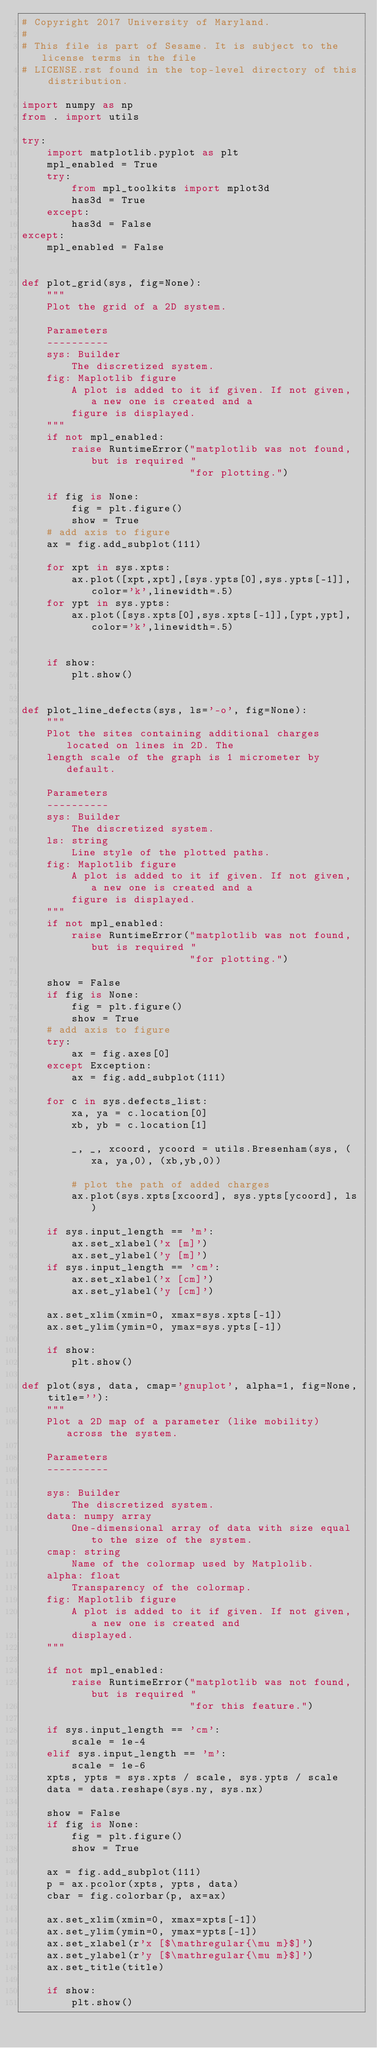<code> <loc_0><loc_0><loc_500><loc_500><_Python_># Copyright 2017 University of Maryland.
#
# This file is part of Sesame. It is subject to the license terms in the file
# LICENSE.rst found in the top-level directory of this distribution.

import numpy as np
from . import utils

try:
    import matplotlib.pyplot as plt
    mpl_enabled = True
    try:
        from mpl_toolkits import mplot3d
        has3d = True
    except:
        has3d = False
except:
    mpl_enabled = False


def plot_grid(sys, fig=None):
    """
    Plot the grid of a 2D system.

    Parameters
    ----------
    sys: Builder
        The discretized system.
    fig: Maplotlib figure
        A plot is added to it if given. If not given, a new one is created and a
        figure is displayed.
    """
    if not mpl_enabled:
        raise RuntimeError("matplotlib was not found, but is required "
                           "for plotting.")

    if fig is None:
        fig = plt.figure()
        show = True
    # add axis to figure
    ax = fig.add_subplot(111)

    for xpt in sys.xpts:
        ax.plot([xpt,xpt],[sys.ypts[0],sys.ypts[-1]],color='k',linewidth=.5)
    for ypt in sys.ypts:
        ax.plot([sys.xpts[0],sys.xpts[-1]],[ypt,ypt],color='k',linewidth=.5)


    if show:
        plt.show()


def plot_line_defects(sys, ls='-o', fig=None):
    """
    Plot the sites containing additional charges located on lines in 2D. The
    length scale of the graph is 1 micrometer by default.

    Parameters
    ----------
    sys: Builder
        The discretized system.
    ls: string
        Line style of the plotted paths.
    fig: Maplotlib figure
        A plot is added to it if given. If not given, a new one is created and a
        figure is displayed.
    """
    if not mpl_enabled:
        raise RuntimeError("matplotlib was not found, but is required "
                           "for plotting.")

    show = False
    if fig is None:
        fig = plt.figure()
        show = True
    # add axis to figure
    try:
        ax = fig.axes[0]
    except Exception:
        ax = fig.add_subplot(111)

    for c in sys.defects_list:
        xa, ya = c.location[0]
        xb, yb = c.location[1]

        _, _, xcoord, ycoord = utils.Bresenham(sys, (xa, ya,0), (xb,yb,0))

        # plot the path of added charges
        ax.plot(sys.xpts[xcoord], sys.ypts[ycoord], ls)

    if sys.input_length == 'm':
        ax.set_xlabel('x [m]')
        ax.set_ylabel('y [m]')
    if sys.input_length == 'cm':
        ax.set_xlabel('x [cm]')
        ax.set_ylabel('y [cm]')
       
    ax.set_xlim(xmin=0, xmax=sys.xpts[-1])
    ax.set_ylim(ymin=0, ymax=sys.ypts[-1])

    if show:
        plt.show()

def plot(sys, data, cmap='gnuplot', alpha=1, fig=None, title=''):
    """
    Plot a 2D map of a parameter (like mobility) across the system.

    Parameters
    ----------

    sys: Builder
        The discretized system.
    data: numpy array
        One-dimensional array of data with size equal to the size of the system.
    cmap: string
        Name of the colormap used by Matplolib.
    alpha: float
        Transparency of the colormap.
    fig: Maplotlib figure
        A plot is added to it if given. If not given, a new one is created and 
        displayed.
    """

    if not mpl_enabled:
        raise RuntimeError("matplotlib was not found, but is required "
                           "for this feature.")

    if sys.input_length == 'cm':
        scale = 1e-4
    elif sys.input_length == 'm':
        scale = 1e-6
    xpts, ypts = sys.xpts / scale, sys.ypts / scale
    data = data.reshape(sys.ny, sys.nx)

    show = False
    if fig is None:
        fig = plt.figure()
        show = True

    ax = fig.add_subplot(111)
    p = ax.pcolor(xpts, ypts, data)
    cbar = fig.colorbar(p, ax=ax)

    ax.set_xlim(xmin=0, xmax=xpts[-1])
    ax.set_ylim(ymin=0, ymax=ypts[-1])
    ax.set_xlabel(r'x [$\mathregular{\mu m}$]')
    ax.set_ylabel(r'y [$\mathregular{\mu m}$]')
    ax.set_title(title)

    if show:
        plt.show()
</code> 